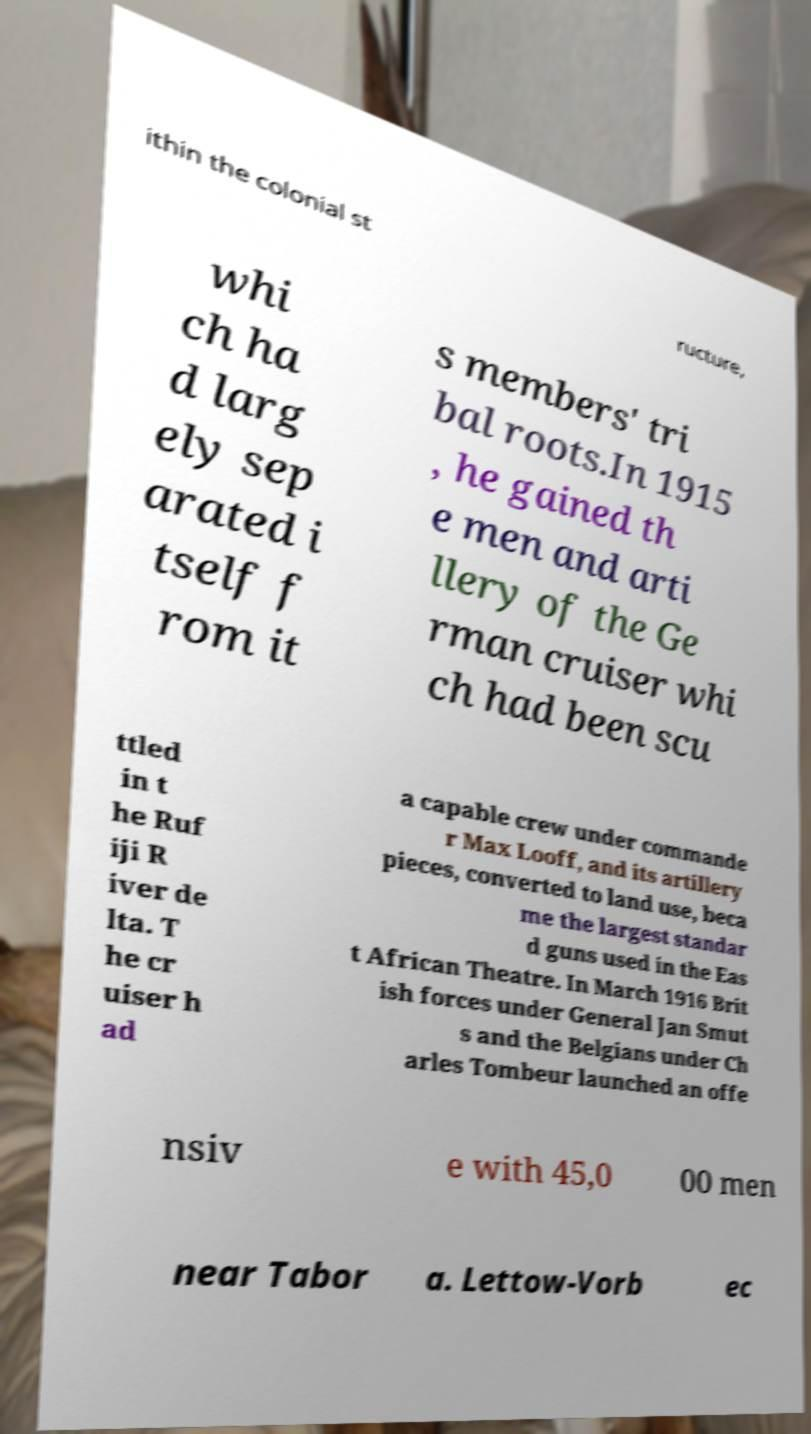Please identify and transcribe the text found in this image. ithin the colonial st ructure, whi ch ha d larg ely sep arated i tself f rom it s members' tri bal roots.In 1915 , he gained th e men and arti llery of the Ge rman cruiser whi ch had been scu ttled in t he Ruf iji R iver de lta. T he cr uiser h ad a capable crew under commande r Max Looff, and its artillery pieces, converted to land use, beca me the largest standar d guns used in the Eas t African Theatre. In March 1916 Brit ish forces under General Jan Smut s and the Belgians under Ch arles Tombeur launched an offe nsiv e with 45,0 00 men near Tabor a. Lettow-Vorb ec 